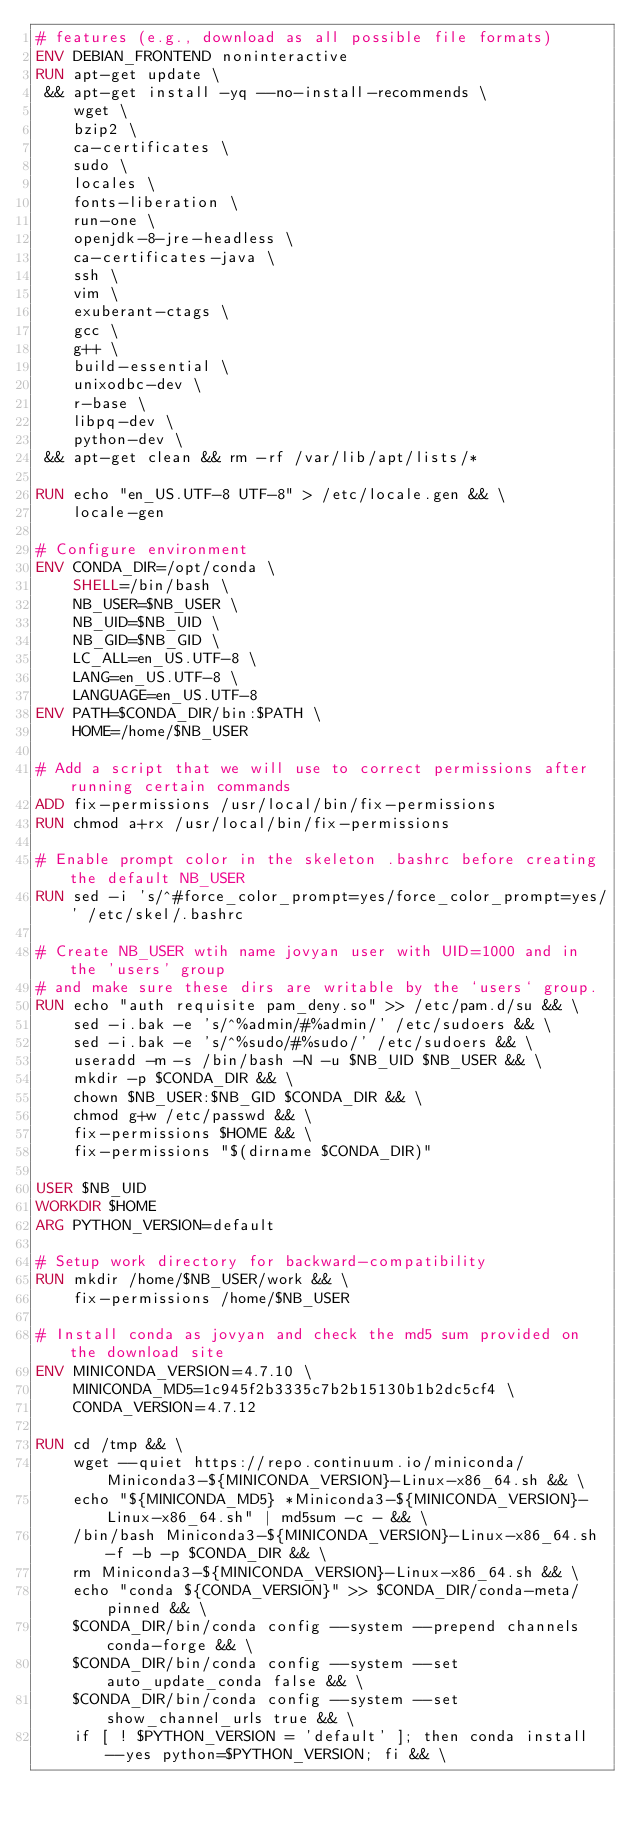Convert code to text. <code><loc_0><loc_0><loc_500><loc_500><_Dockerfile_># features (e.g., download as all possible file formats)
ENV DEBIAN_FRONTEND noninteractive
RUN apt-get update \
 && apt-get install -yq --no-install-recommends \
    wget \
    bzip2 \
    ca-certificates \
    sudo \
    locales \
    fonts-liberation \
    run-one \
    openjdk-8-jre-headless \ 
    ca-certificates-java \
    ssh \
    vim \
    exuberant-ctags \
    gcc \
    g++ \
    build-essential \
    unixodbc-dev \
    r-base \
    libpq-dev \
    python-dev \
 && apt-get clean && rm -rf /var/lib/apt/lists/*

RUN echo "en_US.UTF-8 UTF-8" > /etc/locale.gen && \
    locale-gen

# Configure environment
ENV CONDA_DIR=/opt/conda \
    SHELL=/bin/bash \
    NB_USER=$NB_USER \
    NB_UID=$NB_UID \
    NB_GID=$NB_GID \
    LC_ALL=en_US.UTF-8 \
    LANG=en_US.UTF-8 \
    LANGUAGE=en_US.UTF-8
ENV PATH=$CONDA_DIR/bin:$PATH \
    HOME=/home/$NB_USER

# Add a script that we will use to correct permissions after running certain commands
ADD fix-permissions /usr/local/bin/fix-permissions
RUN chmod a+rx /usr/local/bin/fix-permissions

# Enable prompt color in the skeleton .bashrc before creating the default NB_USER
RUN sed -i 's/^#force_color_prompt=yes/force_color_prompt=yes/' /etc/skel/.bashrc

# Create NB_USER wtih name jovyan user with UID=1000 and in the 'users' group
# and make sure these dirs are writable by the `users` group.
RUN echo "auth requisite pam_deny.so" >> /etc/pam.d/su && \
    sed -i.bak -e 's/^%admin/#%admin/' /etc/sudoers && \
    sed -i.bak -e 's/^%sudo/#%sudo/' /etc/sudoers && \
    useradd -m -s /bin/bash -N -u $NB_UID $NB_USER && \
    mkdir -p $CONDA_DIR && \
    chown $NB_USER:$NB_GID $CONDA_DIR && \
    chmod g+w /etc/passwd && \
    fix-permissions $HOME && \
    fix-permissions "$(dirname $CONDA_DIR)"

USER $NB_UID
WORKDIR $HOME
ARG PYTHON_VERSION=default

# Setup work directory for backward-compatibility
RUN mkdir /home/$NB_USER/work && \
    fix-permissions /home/$NB_USER

# Install conda as jovyan and check the md5 sum provided on the download site
ENV MINICONDA_VERSION=4.7.10 \
    MINICONDA_MD5=1c945f2b3335c7b2b15130b1b2dc5cf4 \
    CONDA_VERSION=4.7.12

RUN cd /tmp && \
    wget --quiet https://repo.continuum.io/miniconda/Miniconda3-${MINICONDA_VERSION}-Linux-x86_64.sh && \
    echo "${MINICONDA_MD5} *Miniconda3-${MINICONDA_VERSION}-Linux-x86_64.sh" | md5sum -c - && \
    /bin/bash Miniconda3-${MINICONDA_VERSION}-Linux-x86_64.sh -f -b -p $CONDA_DIR && \
    rm Miniconda3-${MINICONDA_VERSION}-Linux-x86_64.sh && \
    echo "conda ${CONDA_VERSION}" >> $CONDA_DIR/conda-meta/pinned && \
    $CONDA_DIR/bin/conda config --system --prepend channels conda-forge && \
    $CONDA_DIR/bin/conda config --system --set auto_update_conda false && \
    $CONDA_DIR/bin/conda config --system --set show_channel_urls true && \
    if [ ! $PYTHON_VERSION = 'default' ]; then conda install --yes python=$PYTHON_VERSION; fi && \</code> 